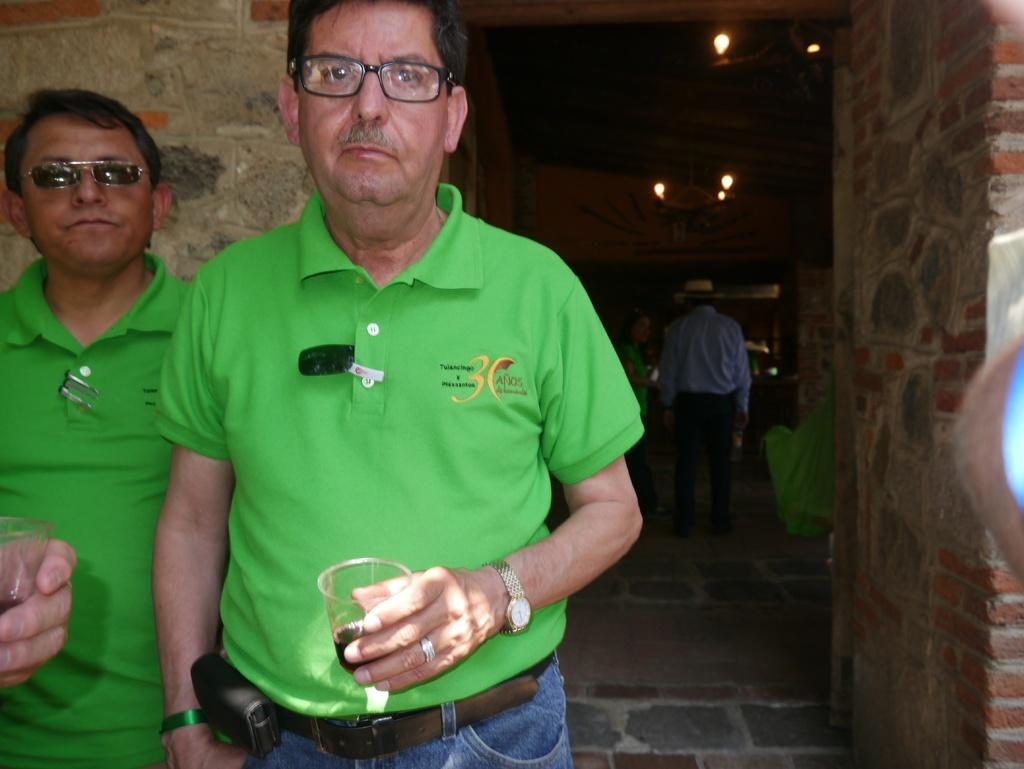How many men are in the image? There are two men in the image. What are the men holding in their hands? The men are holding wine glasses. What can be seen at the top of the image? There are lights visible at the top of the image. What type of structure is on the right side of the image? There is a brick wall on the right side of the image. How far away is the nearest object being attacked in the image? There is no object being attacked in the image. 